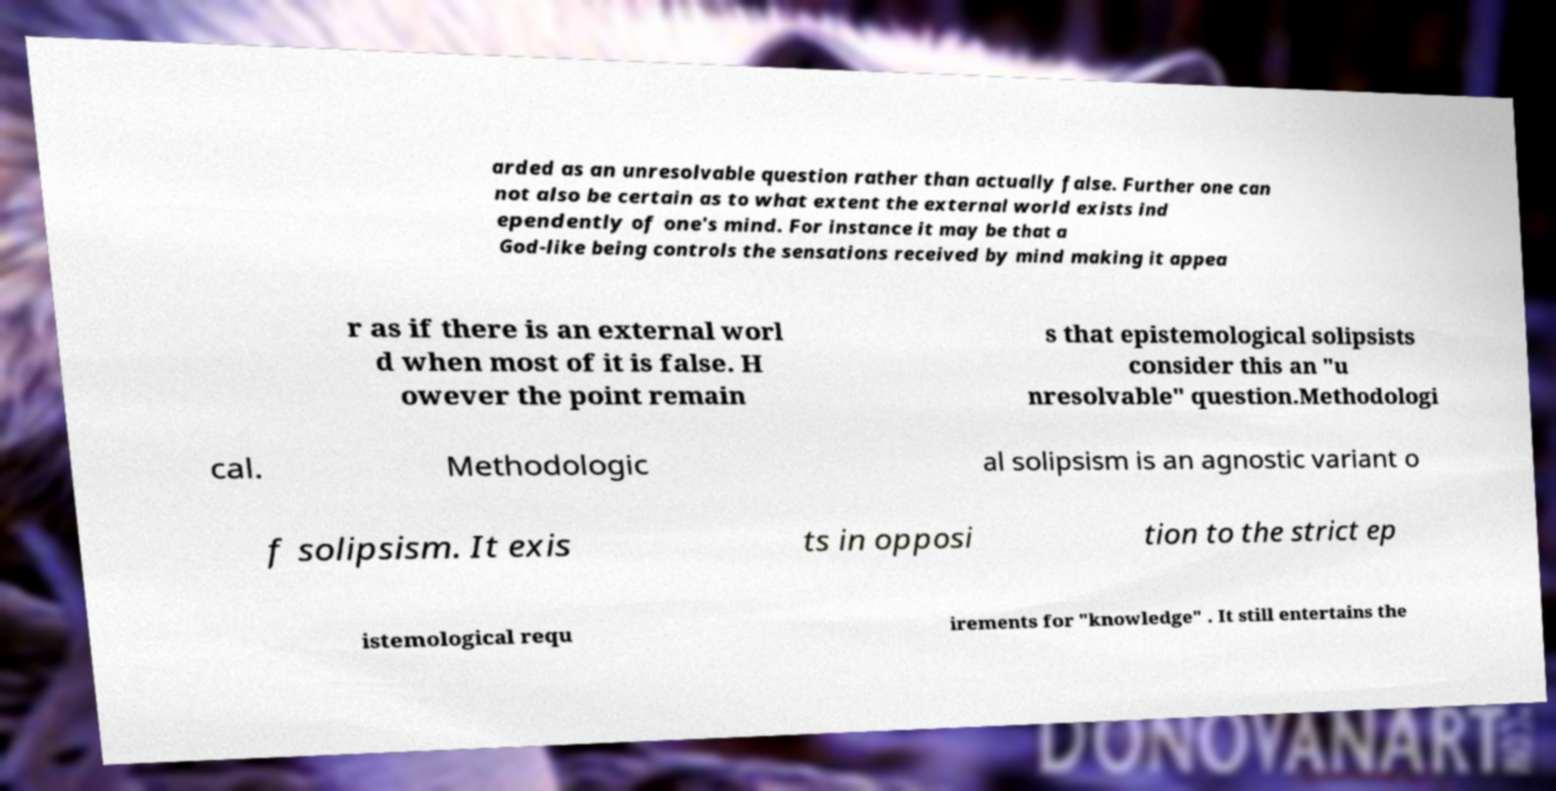I need the written content from this picture converted into text. Can you do that? arded as an unresolvable question rather than actually false. Further one can not also be certain as to what extent the external world exists ind ependently of one's mind. For instance it may be that a God-like being controls the sensations received by mind making it appea r as if there is an external worl d when most of it is false. H owever the point remain s that epistemological solipsists consider this an "u nresolvable" question.Methodologi cal. Methodologic al solipsism is an agnostic variant o f solipsism. It exis ts in opposi tion to the strict ep istemological requ irements for "knowledge" . It still entertains the 